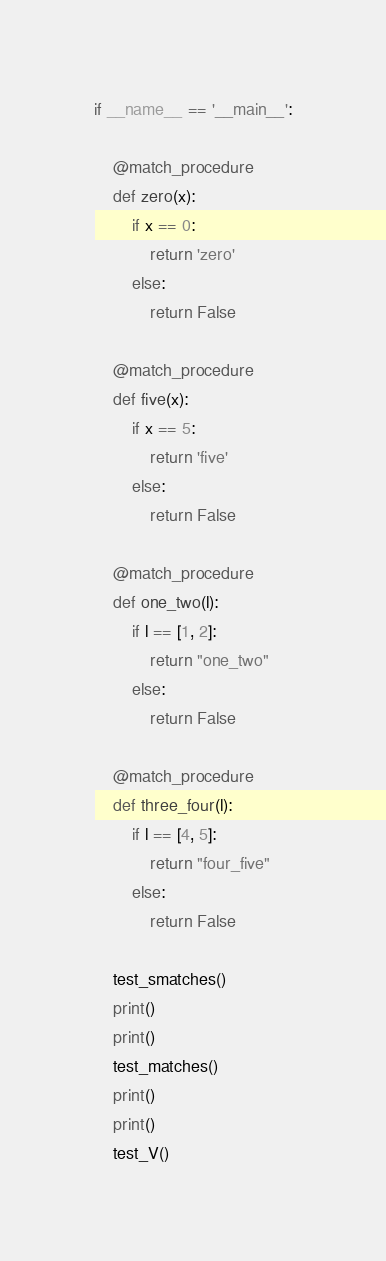Convert code to text. <code><loc_0><loc_0><loc_500><loc_500><_Python_>
if __name__ == '__main__':

    @match_procedure
    def zero(x):
        if x == 0:
            return 'zero'
        else:
            return False

    @match_procedure
    def five(x):
        if x == 5:
            return 'five'
        else:
            return False

    @match_procedure
    def one_two(l):
        if l == [1, 2]:
            return "one_two"
        else:
            return False

    @match_procedure
    def three_four(l):
        if l == [4, 5]:
            return "four_five"
        else:
            return False

    test_smatches()
    print()
    print()
    test_matches()
    print()
    print()
    test_V()
</code> 